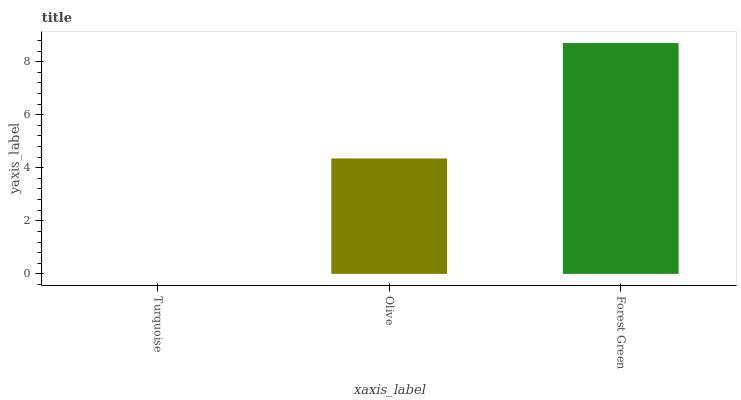Is Turquoise the minimum?
Answer yes or no. Yes. Is Forest Green the maximum?
Answer yes or no. Yes. Is Olive the minimum?
Answer yes or no. No. Is Olive the maximum?
Answer yes or no. No. Is Olive greater than Turquoise?
Answer yes or no. Yes. Is Turquoise less than Olive?
Answer yes or no. Yes. Is Turquoise greater than Olive?
Answer yes or no. No. Is Olive less than Turquoise?
Answer yes or no. No. Is Olive the high median?
Answer yes or no. Yes. Is Olive the low median?
Answer yes or no. Yes. Is Forest Green the high median?
Answer yes or no. No. Is Turquoise the low median?
Answer yes or no. No. 